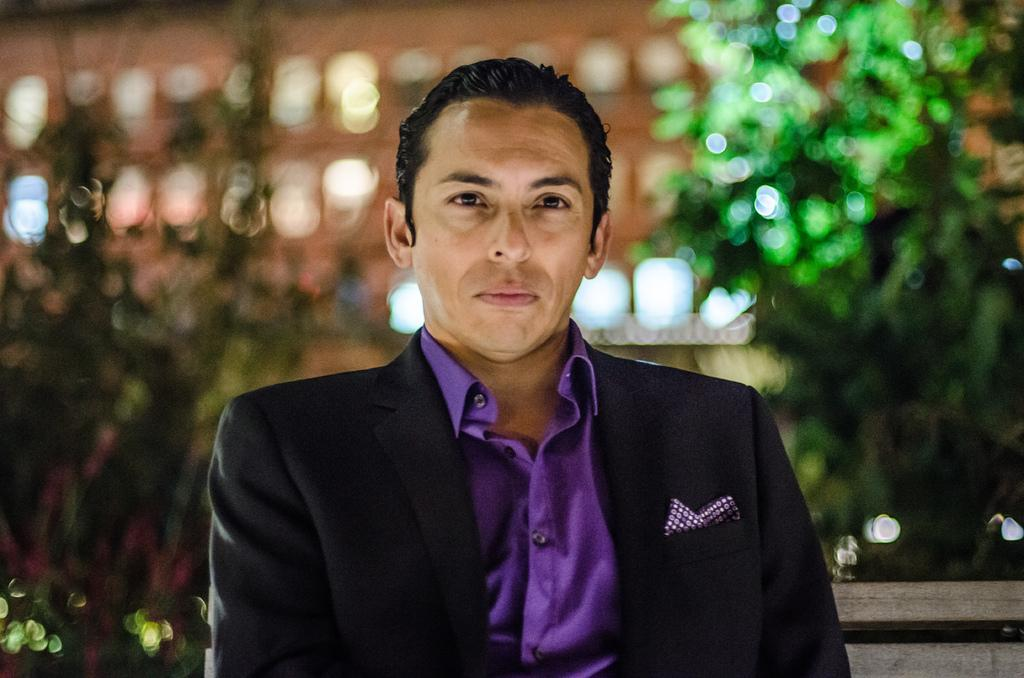Who or what is present in the image? There is a person in the image. What is the person wearing? The person is wearing a black jacket. What can be seen in the background of the image? There are lights visible in the background of the image. What type of furniture is being used by the person in the image? There is no furniture visible in the image; it only shows a person wearing a black jacket and lights in the background. 